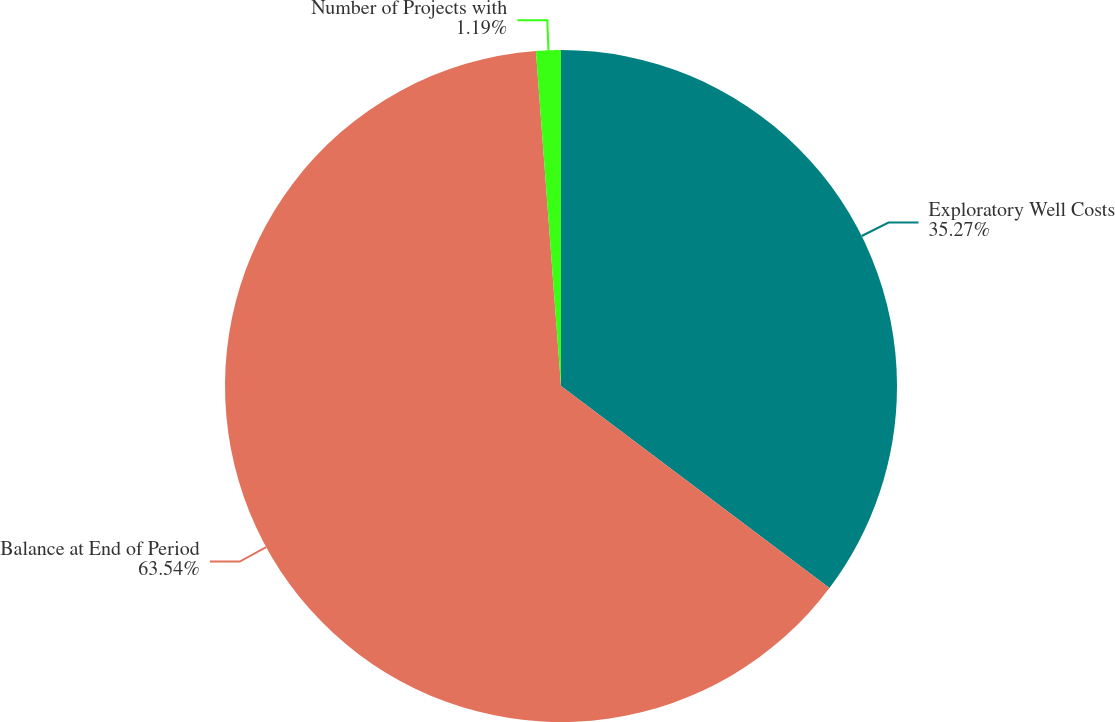<chart> <loc_0><loc_0><loc_500><loc_500><pie_chart><fcel>Exploratory Well Costs<fcel>Balance at End of Period<fcel>Number of Projects with<nl><fcel>35.27%<fcel>63.54%<fcel>1.19%<nl></chart> 